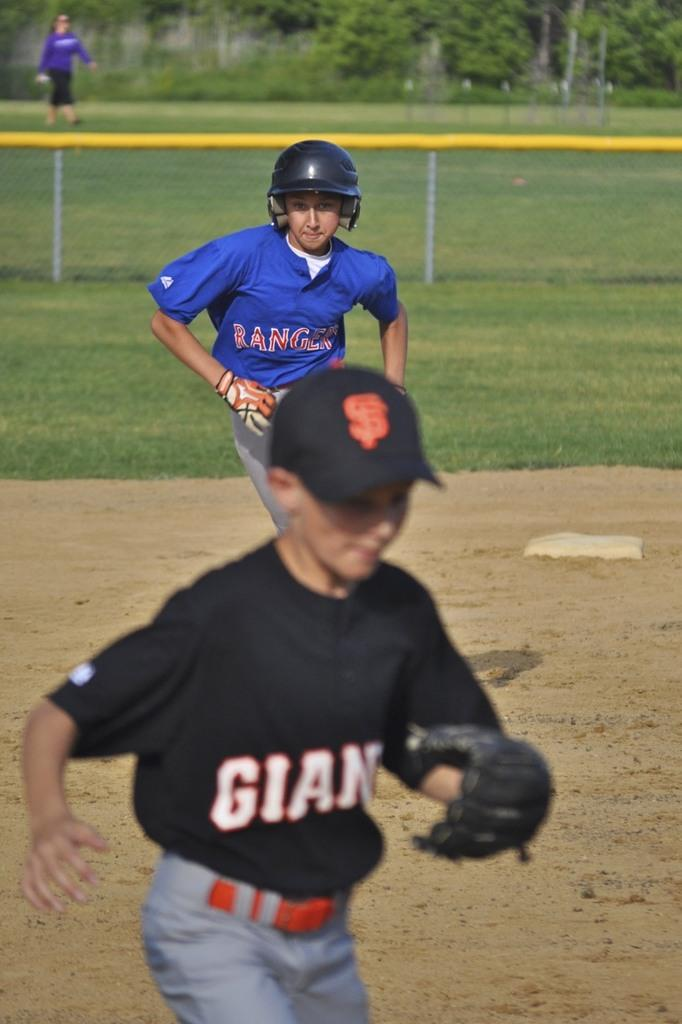<image>
Relay a brief, clear account of the picture shown. A baseball game between the Rangers and the Giants. 